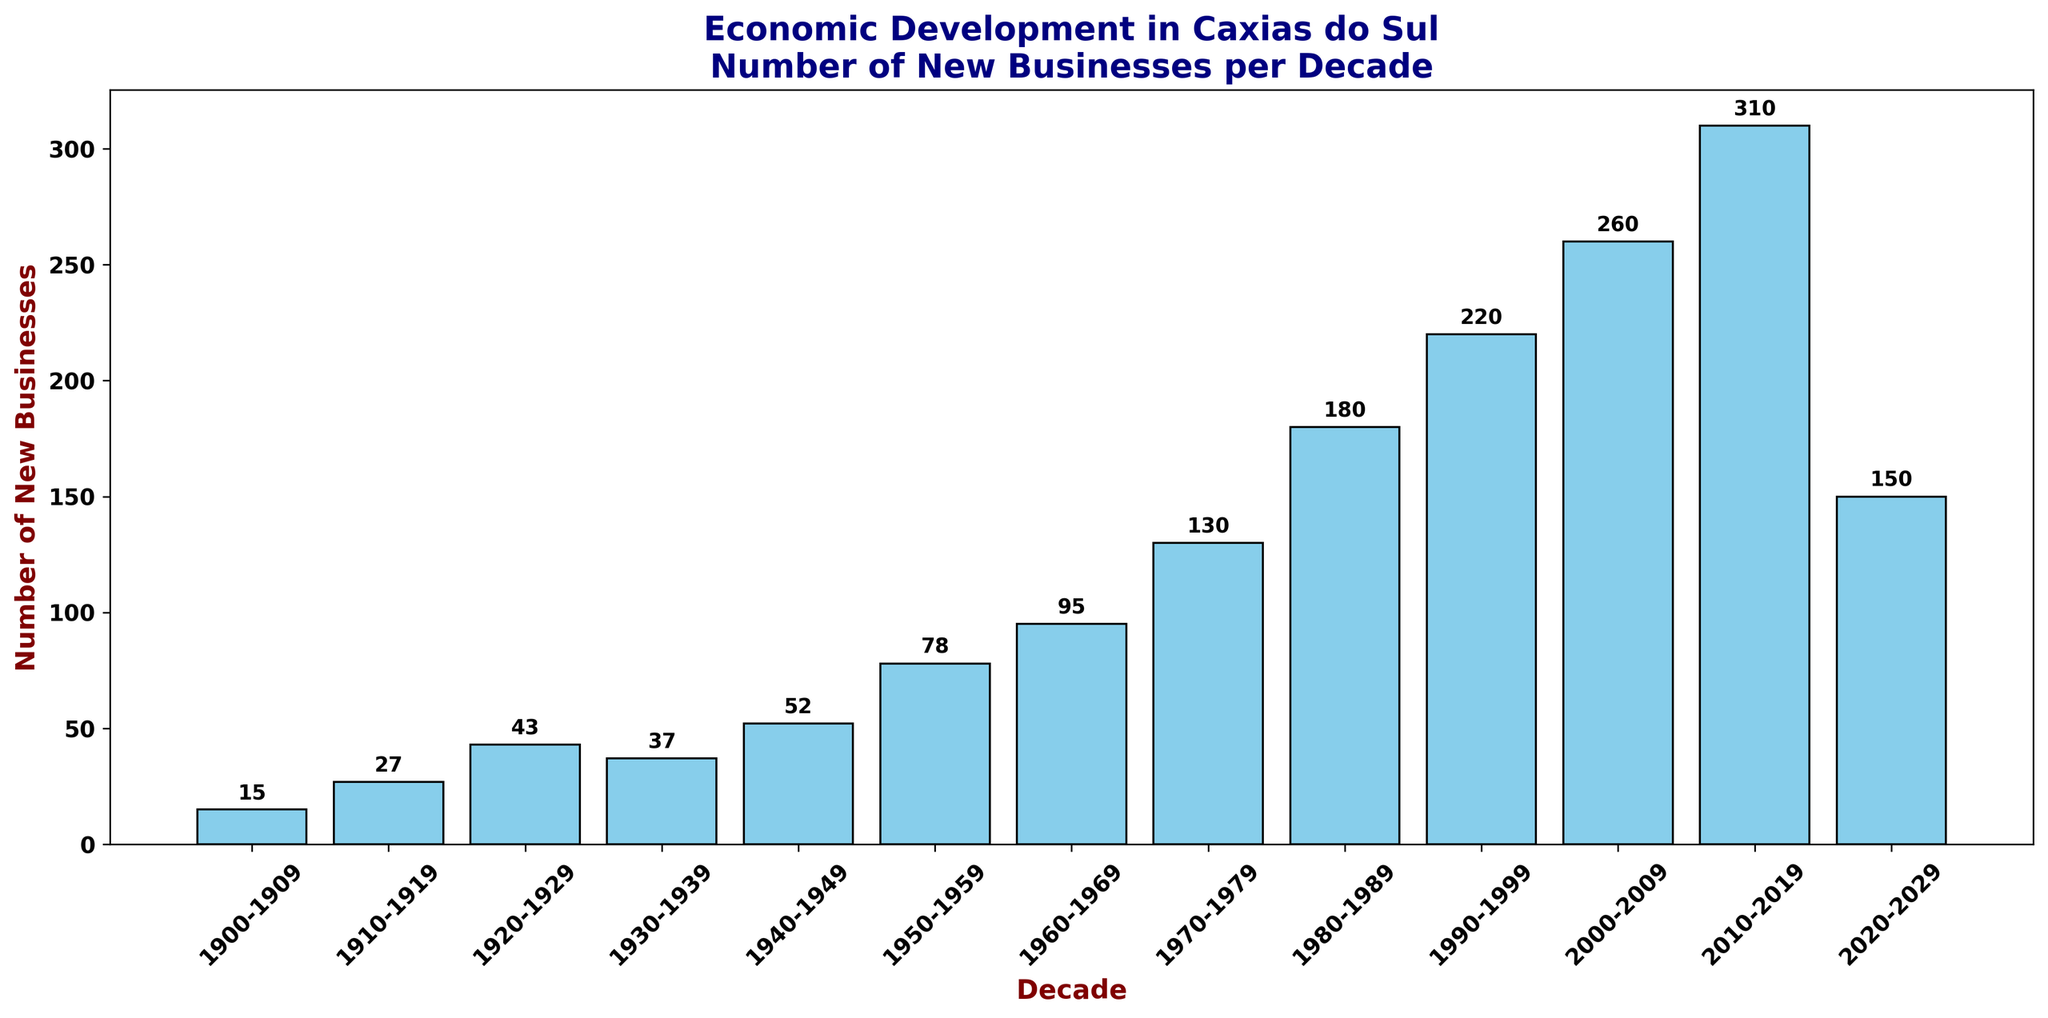What's the decade with the highest number of new businesses established? Observe the height of all the bars. The tallest bar corresponds to the 2010-2019 decade, indicating that this period saw the highest number of new businesses.
Answer: 2010-2019 Which decade saw a sudden drop in the number of new businesses compared to the previous one? Compare the height of each bar with the one immediately preceding it. The most noticeable decrease is from 2010-2019 (310 new businesses) to 2020-2029 (150 new businesses).
Answer: 2020-2029 Calculate the total number of new businesses established from 1900 to 1949. Sum the number of new businesses for the decades 1900-1909, 1910-1919, 1920-1929, 1930-1939, and 1940-1949. That is, 15 + 27 + 43 + 37 + 52. The total is 174.
Answer: 174 Which two consecutive decades show the greatest increase in the number of new businesses? Determine the increase between each pair of consecutive decades. The largest increase is between 2000-2009 (260 new businesses) and 2010-2019 (310 new businesses), yielding an increase of 50.
Answer: 2000-2009 and 2010-2019 Identify the decades where the number of new businesses established was less than 50. Look at the bars that have a value less than 50. The corresponding decades are 1900-1909 (15), 1910-1919 (27), 1920-1929 (43), and 1930-1939 (37).
Answer: 1900-1909, 1910-1919, 1920-1929, 1930-1939 How much more businesses were established in 2010-2019 compared to 1900-1909? Subtract the number of new businesses in 1900-1909 (15) from the number in 2010-2019 (310). So, 310 - 15 = 295.
Answer: 295 During which decades did the number of new businesses more than double compared to the previous decade? Calculate the ratio of businesses in each decade to the previous one. The decades of interest are:
- 1910-1919 (27/15 = 1.8)
- 1920-1929 (43/27 = 1.59)
- 1930-1939 (37/43 = 0.86)
- 1940-1949 (52/37 = 1.41)
- 1950-1959 (78/52 = 1.5)
- 1960-1969 (95/78 = 1.22)
- 1970-1979 (130/95 = 1.36)
- 1980-1989 (180/130 = 1.38)
- 1990-1999 (220/180 = 1.22)
- 2000-2009 (260/220 = 1.18)
- 2010-2019 (310/260 = 1.19)
- 2020-2029 (150/310 = 0.48)
No decade's count more than doubled compared to its prior.
Answer: None 